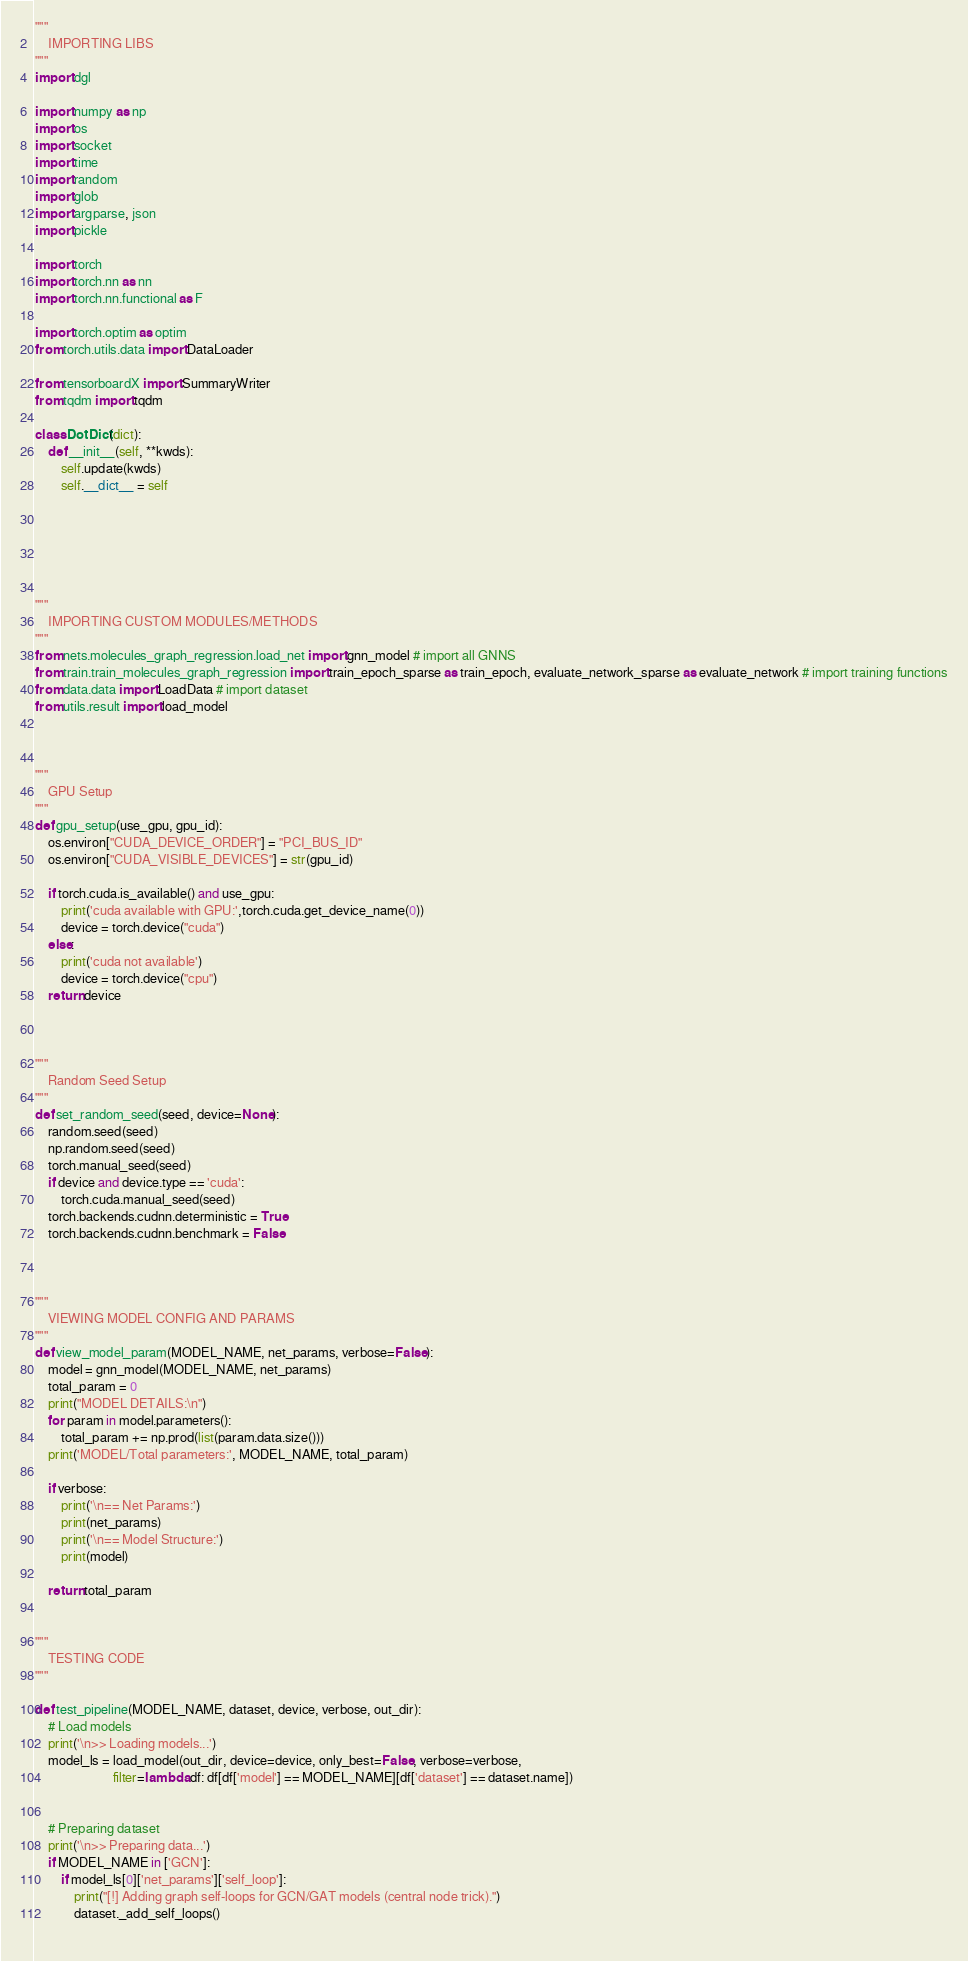<code> <loc_0><loc_0><loc_500><loc_500><_Python_>




"""
    IMPORTING LIBS
"""
import dgl

import numpy as np
import os
import socket
import time
import random
import glob
import argparse, json
import pickle

import torch
import torch.nn as nn
import torch.nn.functional as F

import torch.optim as optim
from torch.utils.data import DataLoader

from tensorboardX import SummaryWriter
from tqdm import tqdm

class DotDict(dict):
    def __init__(self, **kwds):
        self.update(kwds)
        self.__dict__ = self






"""
    IMPORTING CUSTOM MODULES/METHODS
"""
from nets.molecules_graph_regression.load_net import gnn_model # import all GNNS
from train.train_molecules_graph_regression import train_epoch_sparse as train_epoch, evaluate_network_sparse as evaluate_network # import training functions
from data.data import LoadData # import dataset
from utils.result import load_model



"""
    GPU Setup
"""
def gpu_setup(use_gpu, gpu_id):
    os.environ["CUDA_DEVICE_ORDER"] = "PCI_BUS_ID"
    os.environ["CUDA_VISIBLE_DEVICES"] = str(gpu_id)  

    if torch.cuda.is_available() and use_gpu:
        print('cuda available with GPU:',torch.cuda.get_device_name(0))
        device = torch.device("cuda")
    else:
        print('cuda not available')
        device = torch.device("cpu")
    return device



"""
    Random Seed Setup
"""
def set_random_seed(seed, device=None):
    random.seed(seed)
    np.random.seed(seed)
    torch.manual_seed(seed)
    if device and device.type == 'cuda':
        torch.cuda.manual_seed(seed)
    torch.backends.cudnn.deterministic = True
    torch.backends.cudnn.benchmark = False



"""
    VIEWING MODEL CONFIG AND PARAMS
"""
def view_model_param(MODEL_NAME, net_params, verbose=False):
    model = gnn_model(MODEL_NAME, net_params)
    total_param = 0
    print("MODEL DETAILS:\n")
    for param in model.parameters():
        total_param += np.prod(list(param.data.size()))
    print('MODEL/Total parameters:', MODEL_NAME, total_param)

    if verbose:
        print('\n== Net Params:')
        print(net_params)
        print('\n== Model Structure:')
        print(model)
        
    return total_param


"""
    TESTING CODE
"""

def test_pipeline(MODEL_NAME, dataset, device, verbose, out_dir):
    # Load models
    print('\n>> Loading models...')
    model_ls = load_model(out_dir, device=device, only_best=False, verbose=verbose,
                        filter=lambda df: df[df['model'] == MODEL_NAME][df['dataset'] == dataset.name])


    # Preparing dataset
    print('\n>> Preparing data...')
    if MODEL_NAME in ['GCN']:
        if model_ls[0]['net_params']['self_loop']:
            print("[!] Adding graph self-loops for GCN/GAT models (central node trick).")
            dataset._add_self_loops()
    </code> 